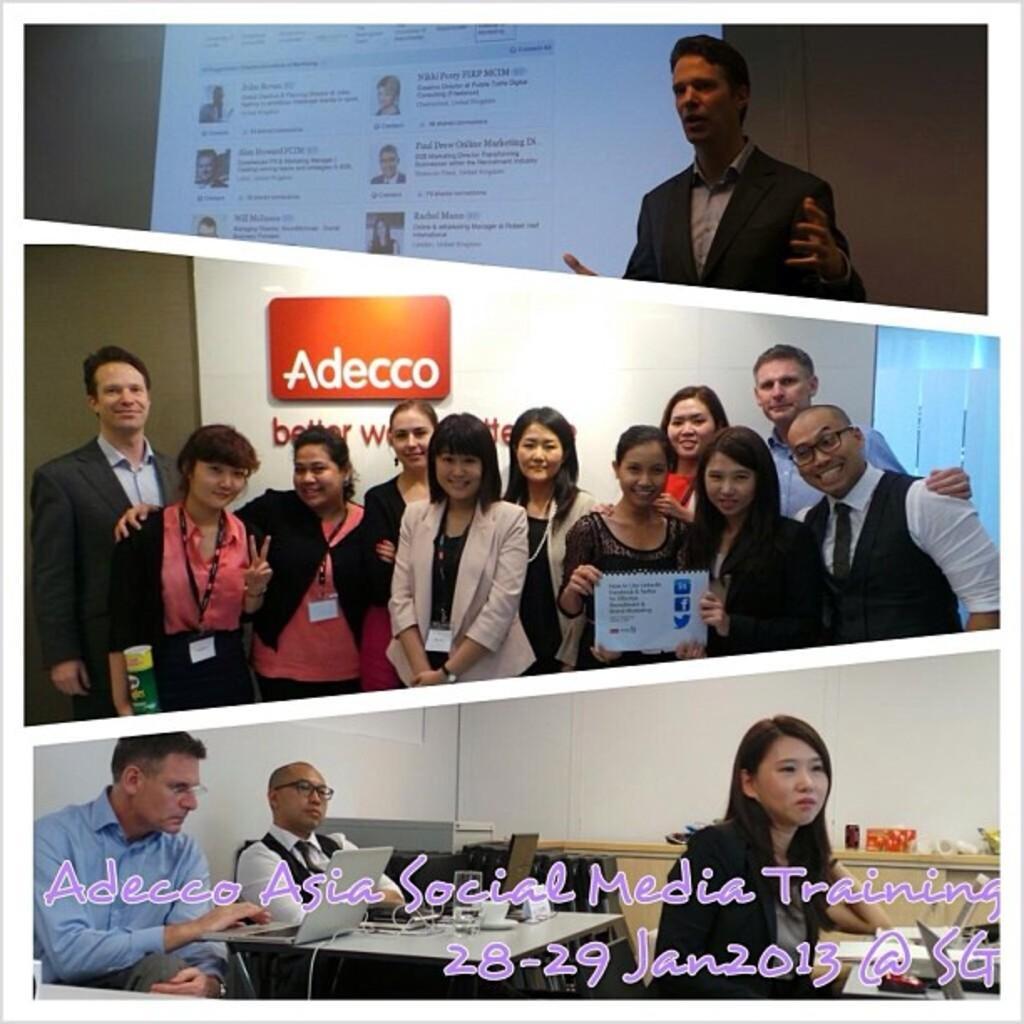How would you summarize this image in a sentence or two? In this image we can see the collage of three pictures. In the top right corner of the image we can see a person wearing a coat. In the center of the image we can see a group of people standing. In the bottom of the image we can see three persons sitting and two laptops and a glass are placed on a table. In the background, we can see a wall with some text on it and a screen. 